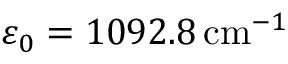<formula> <loc_0><loc_0><loc_500><loc_500>\varepsilon _ { 0 } = 1 0 9 2 . 8 \, c m ^ { - 1 }</formula> 